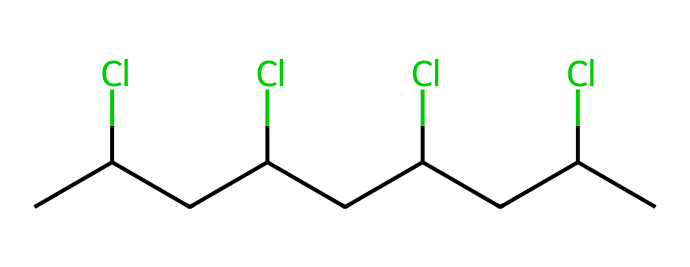How many chlorine atoms are present in this molecule? By examining the SMILES representation, we see the repeated occurrence of "Cl," indicating the presence of chlorine atoms in the structure. Count each occurrence to find the total number. In this case, there are four occurrences of "Cl."
Answer: four What is the main polymer formed from this chemical structure? The SMILES represents polyvinyl chloride, commonly abbreviated as PVC. This is determined by recognizing the repeating units of the structure identified within the SMILES notation.
Answer: polyvinyl chloride How many carbon atoms are present in this polymer? Counting the "C" letters in the SMILES representation reveals the number of carbon atoms. Each carbon atom is represented by a "C," and there are eight occurrences identified.
Answer: eight What type of bonding is predominantly featured in polyvinyl chloride? In the structure, the connections between carbon atoms and the chlorine atoms represent covalent bonds, which are characterized by the sharing of electron pairs. This type of bonding is typical for organic polymers.
Answer: covalent What is a common use of PVC in the context of film tourism? PVC is widely used for making durable promotional banners due to its weather resistance and versatility. This application is relevant in film tourism events where visibility and resilience are important.
Answer: promotional banners How does the presence of chlorine atoms affect the properties of PVC? The chlorine atoms introduce rigidity and chemical resistance to the polymer structure, enhancing its durability and stability compared to other polymers without chlorine. This results in a material that holds up well under outdoor conditions, ideal for banners.
Answer: durability 